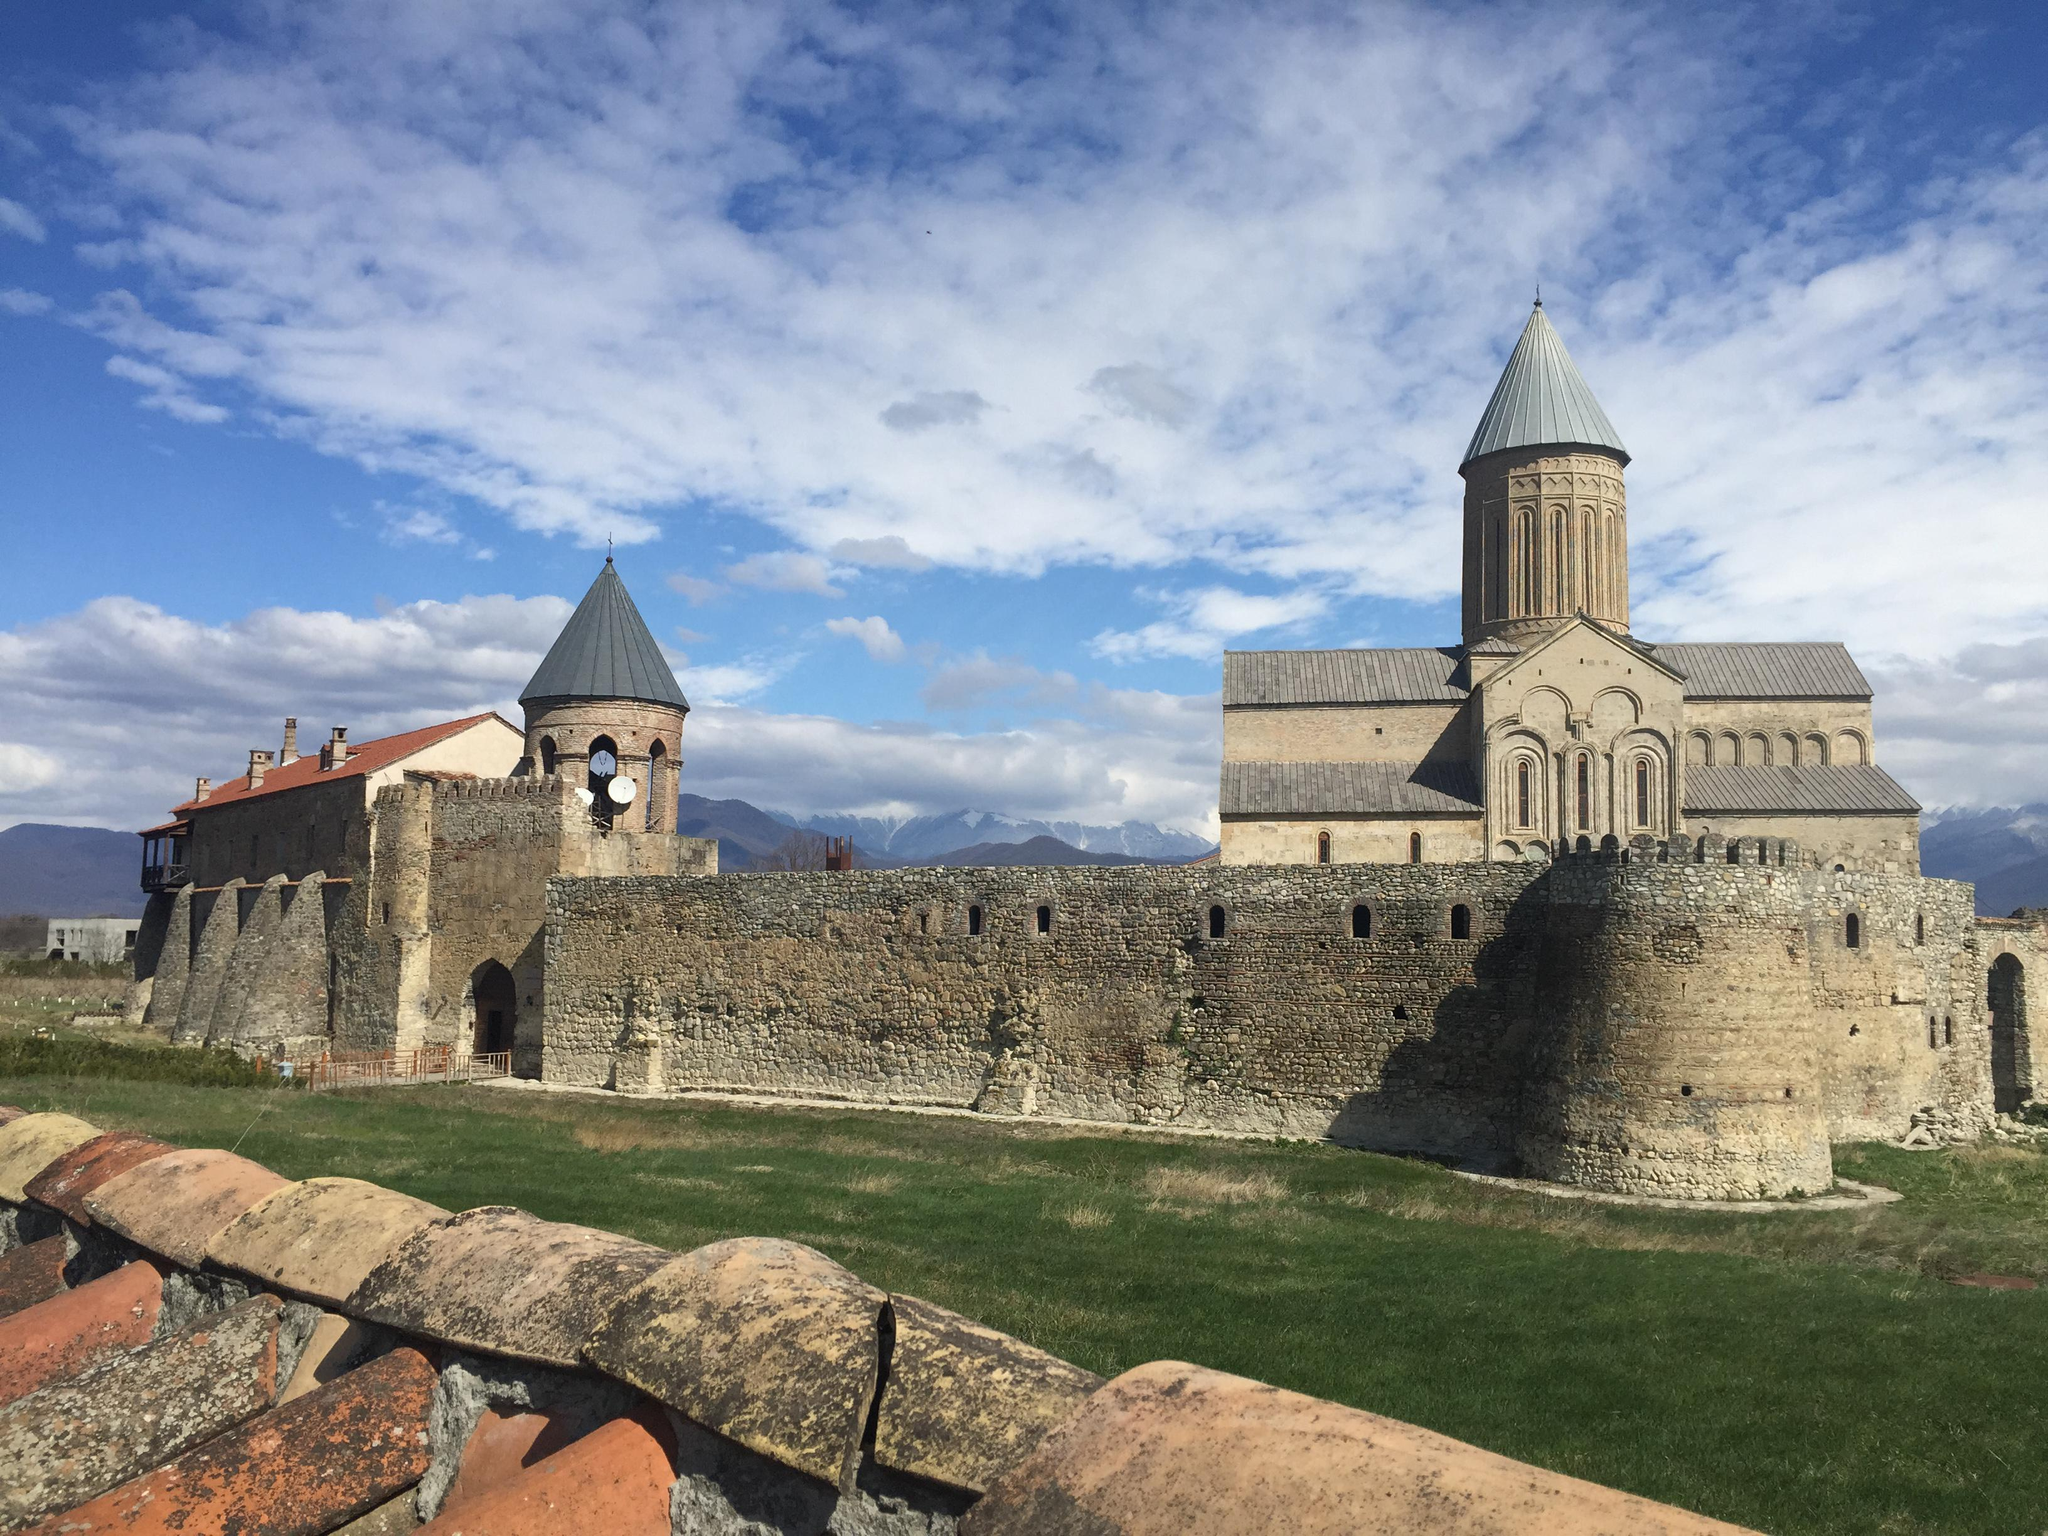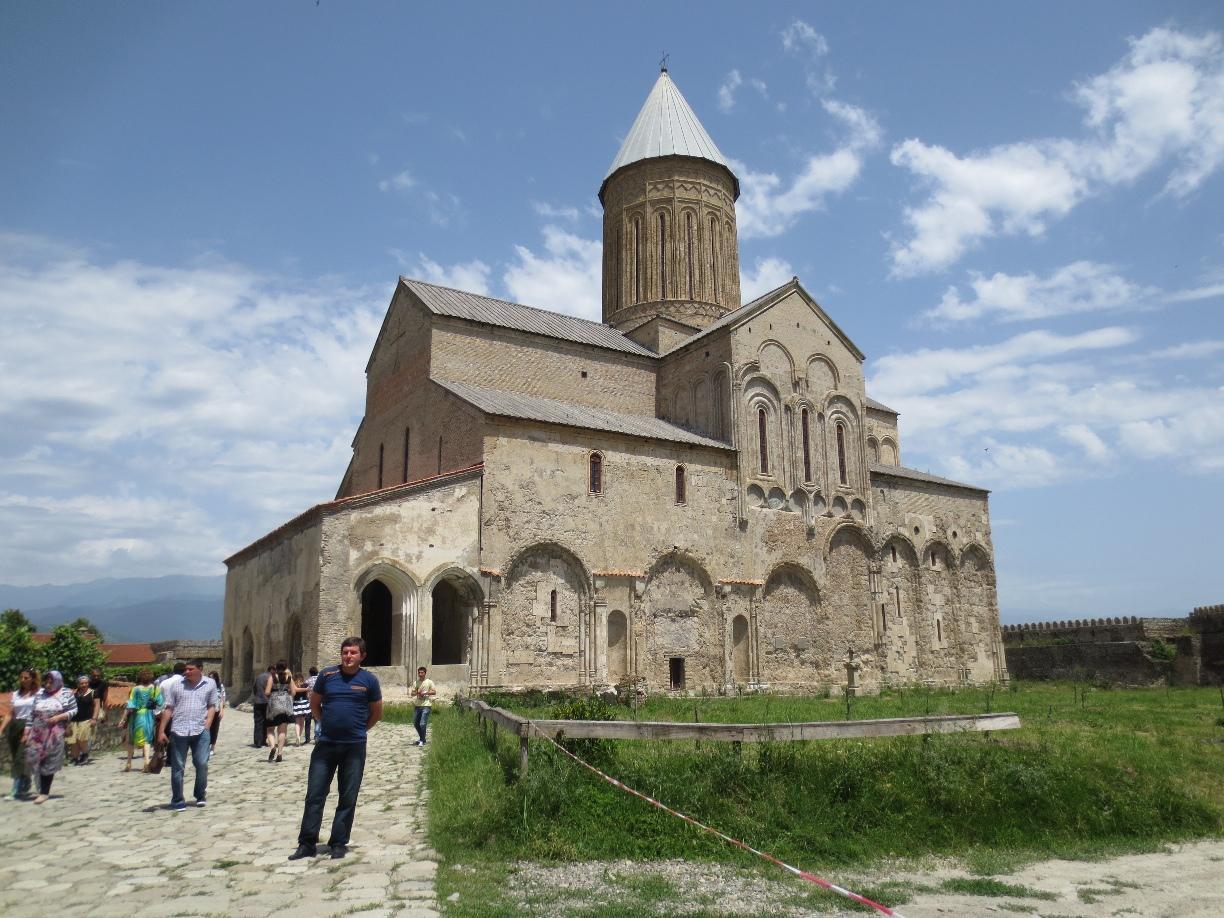The first image is the image on the left, the second image is the image on the right. Examine the images to the left and right. Is the description "There is a stone wall in front of the building in one image, but no stone wall in front of the other." accurate? Answer yes or no. Yes. The first image is the image on the left, the second image is the image on the right. Assess this claim about the two images: "In at least one image there are at least two triangle towers roofs behind a cobblestone wall.". Correct or not? Answer yes or no. Yes. 